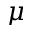Convert formula to latex. <formula><loc_0><loc_0><loc_500><loc_500>{ \mu }</formula> 